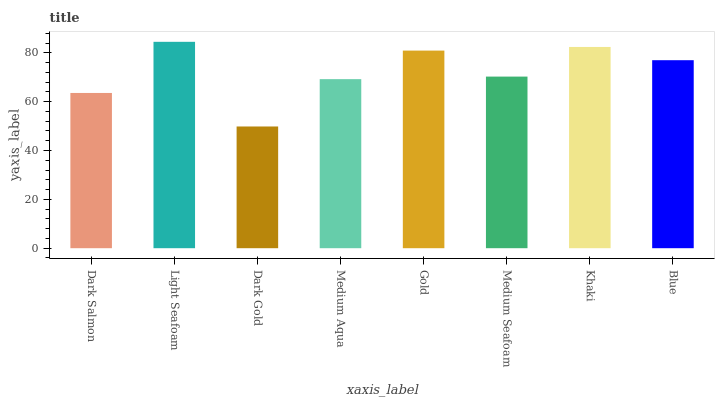Is Light Seafoam the minimum?
Answer yes or no. No. Is Dark Gold the maximum?
Answer yes or no. No. Is Light Seafoam greater than Dark Gold?
Answer yes or no. Yes. Is Dark Gold less than Light Seafoam?
Answer yes or no. Yes. Is Dark Gold greater than Light Seafoam?
Answer yes or no. No. Is Light Seafoam less than Dark Gold?
Answer yes or no. No. Is Blue the high median?
Answer yes or no. Yes. Is Medium Seafoam the low median?
Answer yes or no. Yes. Is Khaki the high median?
Answer yes or no. No. Is Medium Aqua the low median?
Answer yes or no. No. 